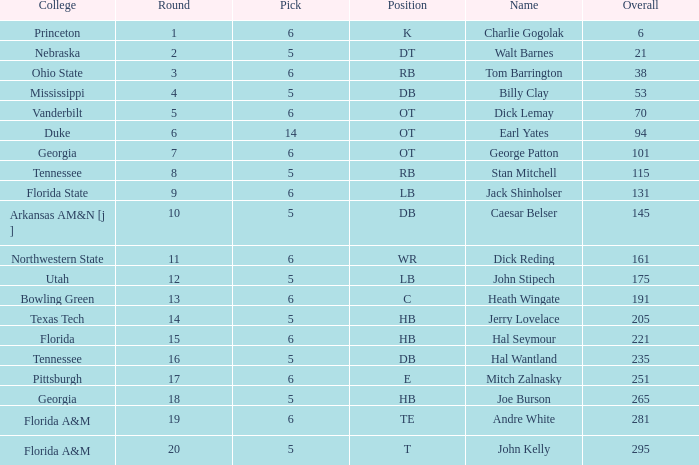When pick is more than 5, round is fewer than 11, and name is "tom barrington", what is the overall sum? 38.0. 